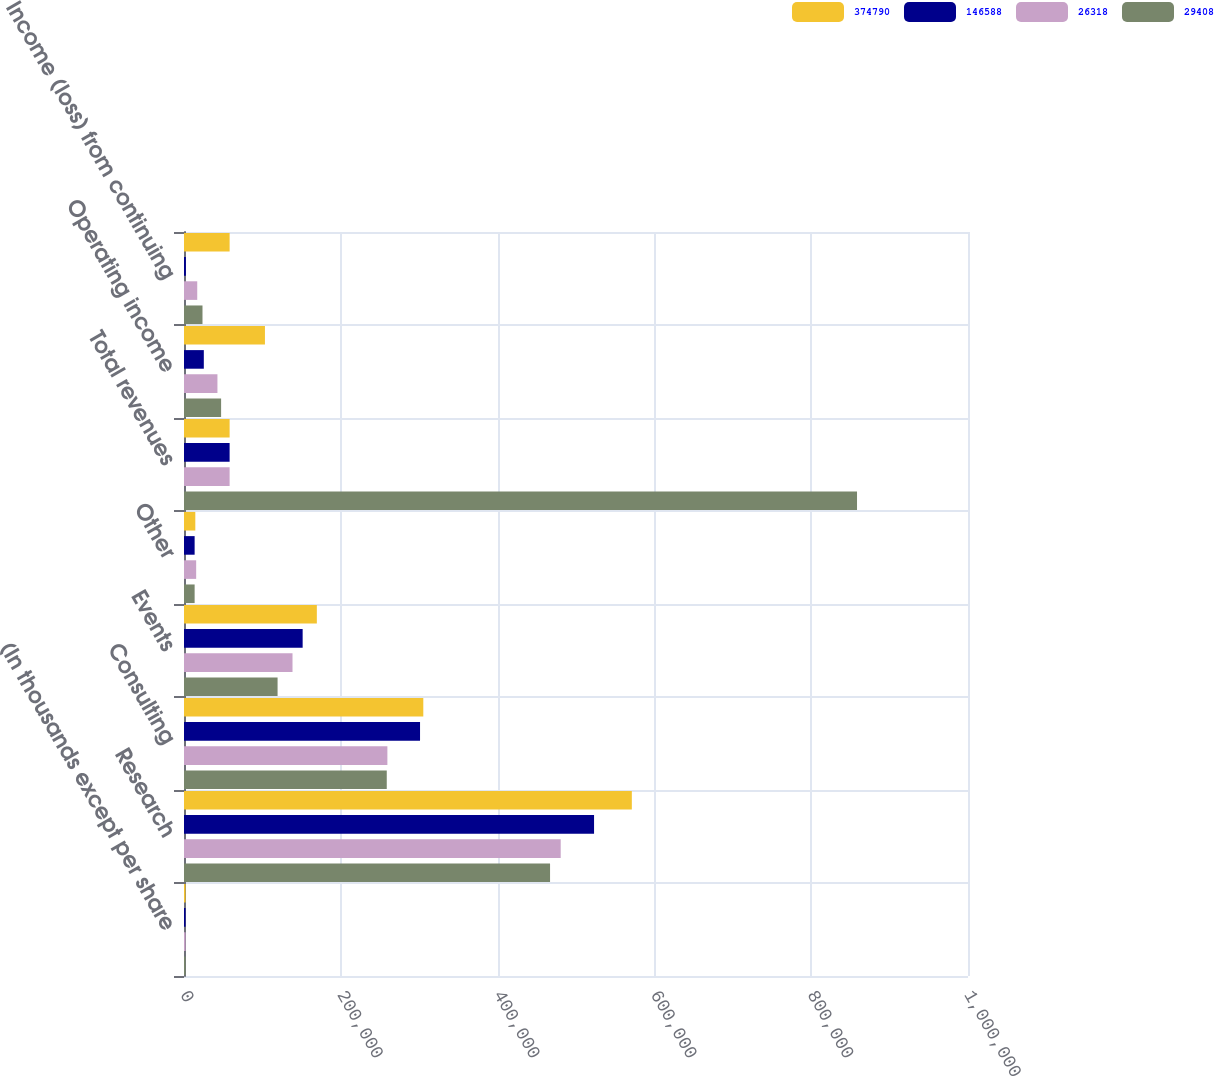<chart> <loc_0><loc_0><loc_500><loc_500><stacked_bar_chart><ecel><fcel>(In thousands except per share<fcel>Research<fcel>Consulting<fcel>Events<fcel>Other<fcel>Total revenues<fcel>Operating income<fcel>Income (loss) from continuing<nl><fcel>374790<fcel>2006<fcel>571217<fcel>305231<fcel>169434<fcel>14439<fcel>58192<fcel>103250<fcel>58192<nl><fcel>146588<fcel>2005<fcel>523033<fcel>301074<fcel>151339<fcel>13558<fcel>58192<fcel>25280<fcel>2437<nl><fcel>26318<fcel>2004<fcel>480486<fcel>259419<fcel>138393<fcel>15523<fcel>58192<fcel>42659<fcel>16889<nl><fcel>29408<fcel>2003<fcel>466907<fcel>258628<fcel>119355<fcel>13556<fcel>858446<fcel>47333<fcel>23589<nl></chart> 